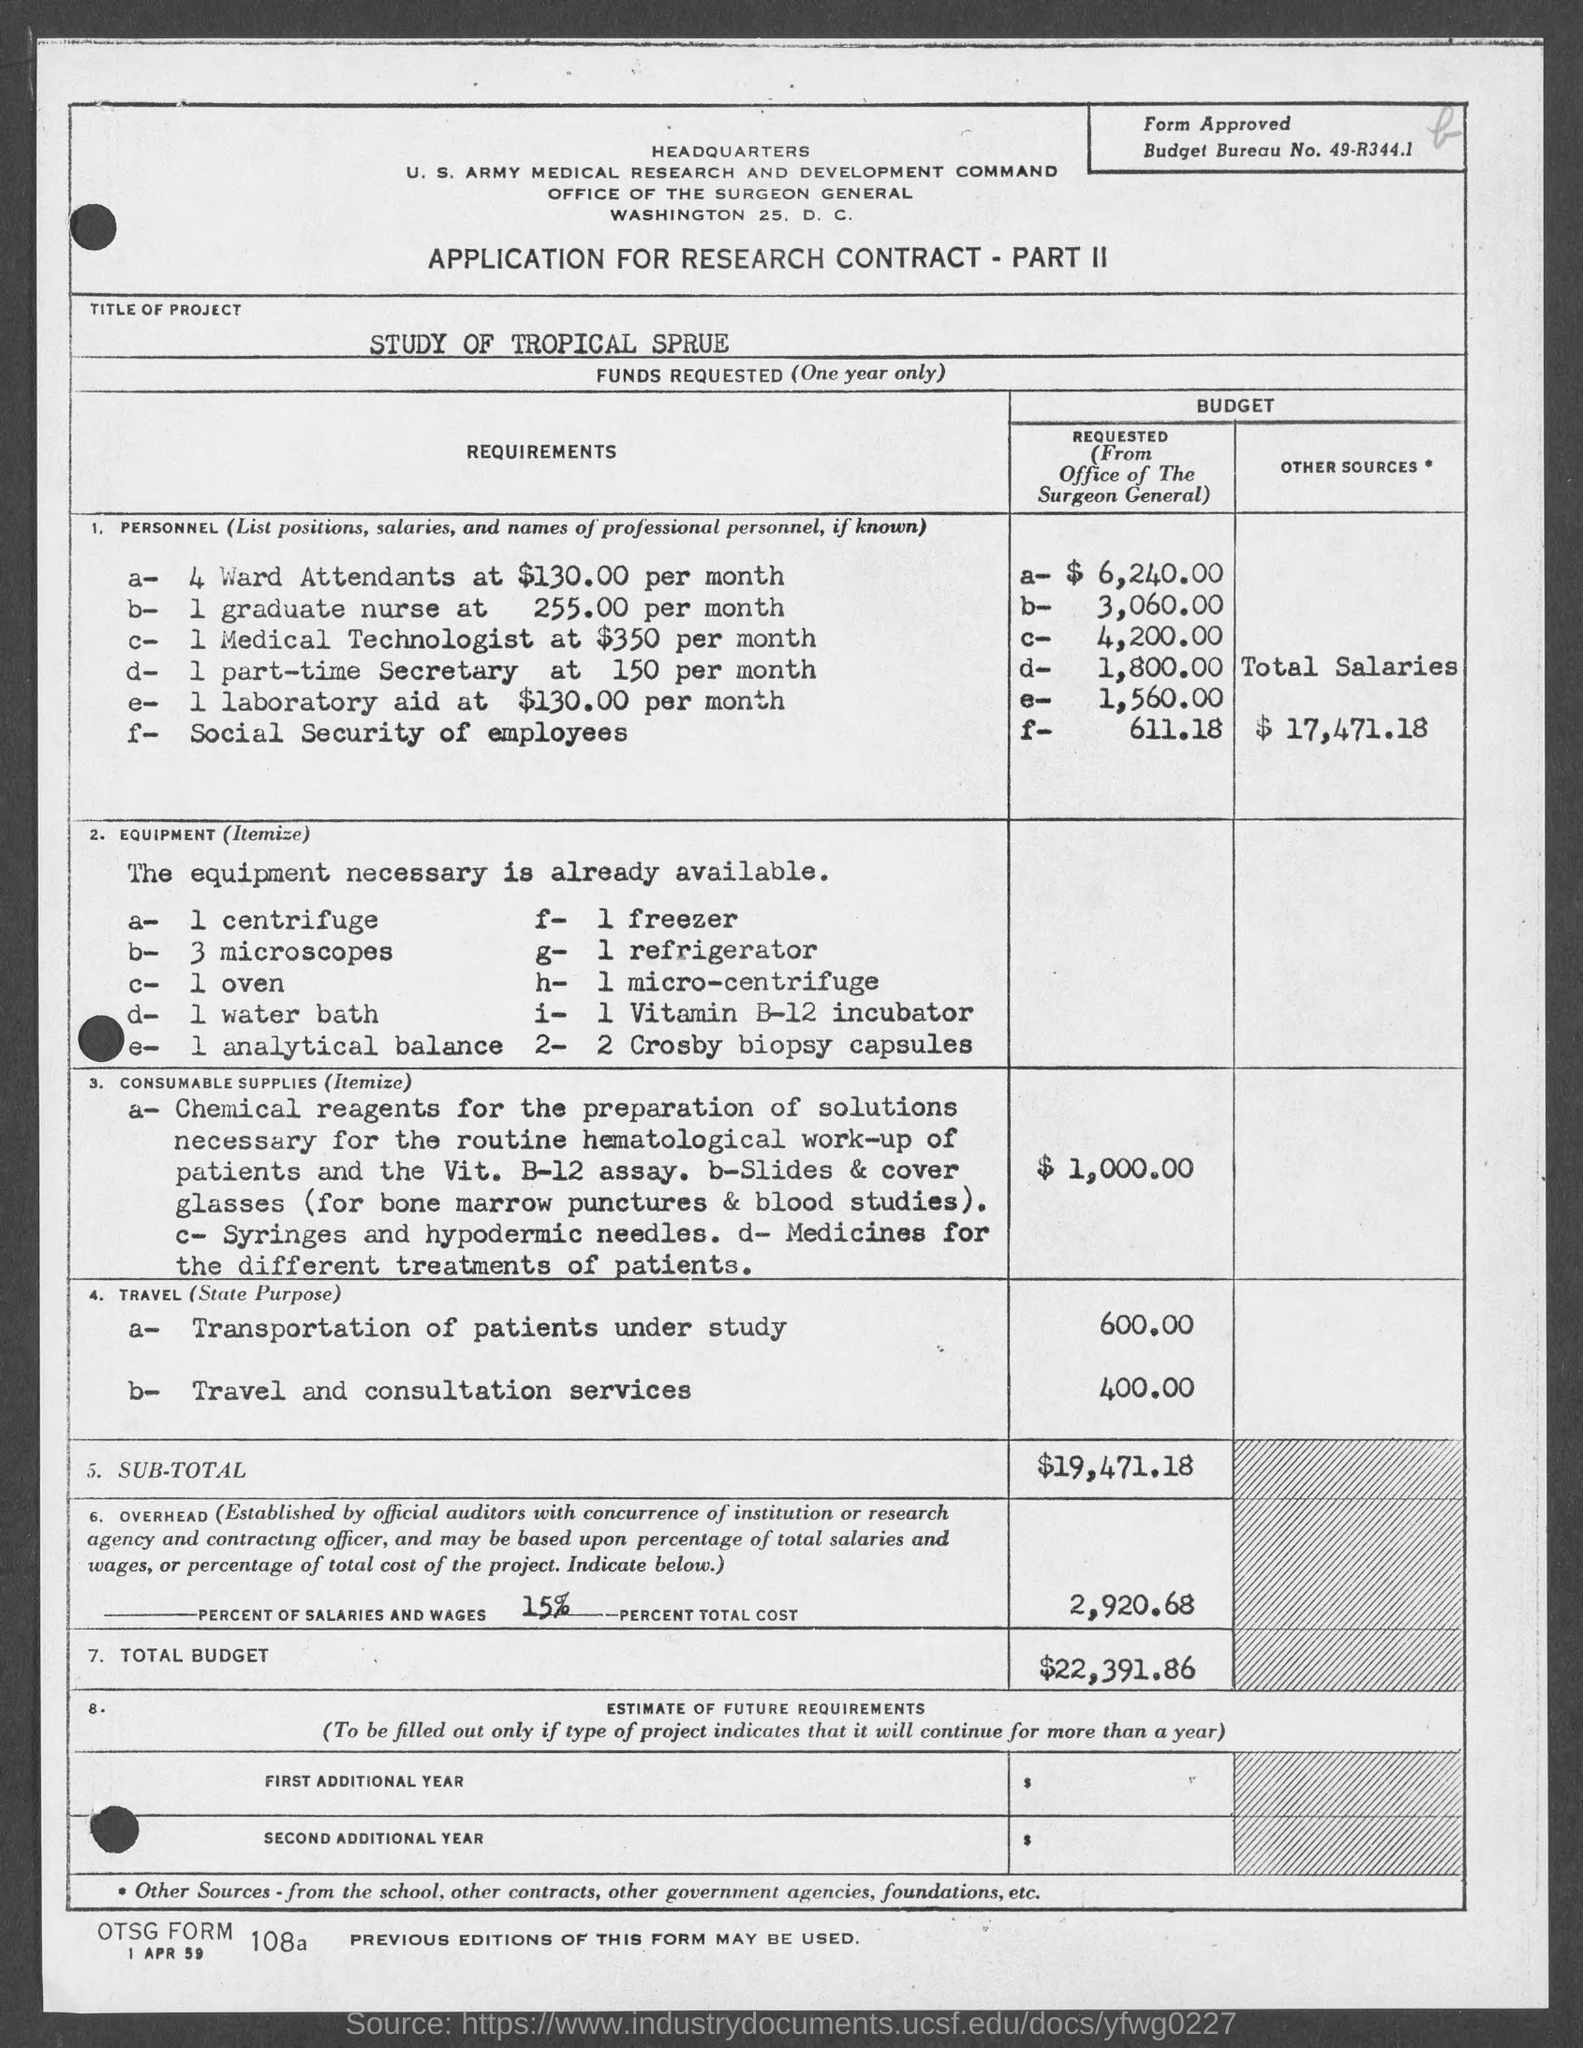Draw attention to some important aspects in this diagram. The cost for Travel and Consultation services is 400.00. The budget bureau number is 49-R344.1... The total salaries for Personnel is $17,471.18. The overhead costs are 2,920.68... The total budget is $22,391.86. 